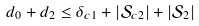<formula> <loc_0><loc_0><loc_500><loc_500>d _ { 0 } + d _ { 2 } & \leq \delta _ { c 1 } + | \mathcal { S } _ { c 2 } | + | \mathcal { S } _ { 2 } |</formula> 